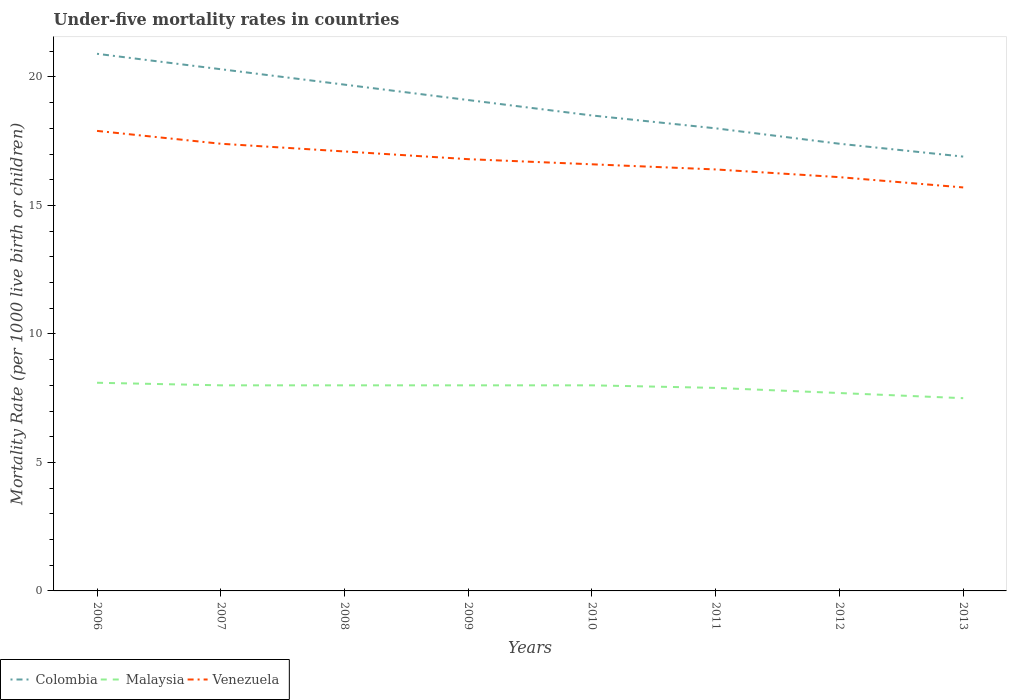Does the line corresponding to Colombia intersect with the line corresponding to Venezuela?
Provide a succinct answer. No. Is the number of lines equal to the number of legend labels?
Give a very brief answer. Yes. Across all years, what is the maximum under-five mortality rate in Colombia?
Provide a short and direct response. 16.9. What is the total under-five mortality rate in Malaysia in the graph?
Your answer should be compact. 0.1. What is the difference between the highest and the second highest under-five mortality rate in Malaysia?
Offer a very short reply. 0.6. How many lines are there?
Your answer should be compact. 3. How many years are there in the graph?
Keep it short and to the point. 8. What is the difference between two consecutive major ticks on the Y-axis?
Keep it short and to the point. 5. Where does the legend appear in the graph?
Provide a succinct answer. Bottom left. What is the title of the graph?
Your answer should be compact. Under-five mortality rates in countries. What is the label or title of the X-axis?
Your answer should be very brief. Years. What is the label or title of the Y-axis?
Offer a terse response. Mortality Rate (per 1000 live birth or children). What is the Mortality Rate (per 1000 live birth or children) of Colombia in 2006?
Give a very brief answer. 20.9. What is the Mortality Rate (per 1000 live birth or children) in Venezuela in 2006?
Your answer should be compact. 17.9. What is the Mortality Rate (per 1000 live birth or children) of Colombia in 2007?
Your answer should be compact. 20.3. What is the Mortality Rate (per 1000 live birth or children) in Malaysia in 2007?
Give a very brief answer. 8. What is the Mortality Rate (per 1000 live birth or children) in Venezuela in 2007?
Offer a very short reply. 17.4. What is the Mortality Rate (per 1000 live birth or children) of Malaysia in 2008?
Give a very brief answer. 8. What is the Mortality Rate (per 1000 live birth or children) in Venezuela in 2008?
Give a very brief answer. 17.1. What is the Mortality Rate (per 1000 live birth or children) of Colombia in 2010?
Ensure brevity in your answer.  18.5. What is the Mortality Rate (per 1000 live birth or children) in Malaysia in 2010?
Ensure brevity in your answer.  8. What is the Mortality Rate (per 1000 live birth or children) in Colombia in 2011?
Provide a succinct answer. 18. What is the Mortality Rate (per 1000 live birth or children) of Malaysia in 2012?
Your response must be concise. 7.7. What is the Mortality Rate (per 1000 live birth or children) in Venezuela in 2013?
Provide a short and direct response. 15.7. Across all years, what is the maximum Mortality Rate (per 1000 live birth or children) of Colombia?
Your response must be concise. 20.9. Across all years, what is the maximum Mortality Rate (per 1000 live birth or children) of Malaysia?
Provide a short and direct response. 8.1. Across all years, what is the minimum Mortality Rate (per 1000 live birth or children) of Malaysia?
Offer a very short reply. 7.5. What is the total Mortality Rate (per 1000 live birth or children) in Colombia in the graph?
Provide a succinct answer. 150.8. What is the total Mortality Rate (per 1000 live birth or children) of Malaysia in the graph?
Ensure brevity in your answer.  63.2. What is the total Mortality Rate (per 1000 live birth or children) of Venezuela in the graph?
Provide a short and direct response. 134. What is the difference between the Mortality Rate (per 1000 live birth or children) in Colombia in 2006 and that in 2007?
Give a very brief answer. 0.6. What is the difference between the Mortality Rate (per 1000 live birth or children) in Malaysia in 2006 and that in 2008?
Give a very brief answer. 0.1. What is the difference between the Mortality Rate (per 1000 live birth or children) in Colombia in 2006 and that in 2009?
Offer a very short reply. 1.8. What is the difference between the Mortality Rate (per 1000 live birth or children) in Colombia in 2006 and that in 2010?
Keep it short and to the point. 2.4. What is the difference between the Mortality Rate (per 1000 live birth or children) of Malaysia in 2006 and that in 2010?
Give a very brief answer. 0.1. What is the difference between the Mortality Rate (per 1000 live birth or children) of Colombia in 2006 and that in 2011?
Offer a terse response. 2.9. What is the difference between the Mortality Rate (per 1000 live birth or children) in Malaysia in 2006 and that in 2011?
Offer a terse response. 0.2. What is the difference between the Mortality Rate (per 1000 live birth or children) in Colombia in 2006 and that in 2012?
Provide a short and direct response. 3.5. What is the difference between the Mortality Rate (per 1000 live birth or children) of Venezuela in 2006 and that in 2012?
Give a very brief answer. 1.8. What is the difference between the Mortality Rate (per 1000 live birth or children) in Venezuela in 2006 and that in 2013?
Offer a terse response. 2.2. What is the difference between the Mortality Rate (per 1000 live birth or children) in Malaysia in 2007 and that in 2008?
Keep it short and to the point. 0. What is the difference between the Mortality Rate (per 1000 live birth or children) of Colombia in 2007 and that in 2009?
Offer a terse response. 1.2. What is the difference between the Mortality Rate (per 1000 live birth or children) of Venezuela in 2007 and that in 2009?
Your answer should be compact. 0.6. What is the difference between the Mortality Rate (per 1000 live birth or children) in Venezuela in 2007 and that in 2010?
Ensure brevity in your answer.  0.8. What is the difference between the Mortality Rate (per 1000 live birth or children) in Colombia in 2007 and that in 2011?
Offer a very short reply. 2.3. What is the difference between the Mortality Rate (per 1000 live birth or children) in Malaysia in 2007 and that in 2011?
Provide a short and direct response. 0.1. What is the difference between the Mortality Rate (per 1000 live birth or children) of Venezuela in 2007 and that in 2011?
Keep it short and to the point. 1. What is the difference between the Mortality Rate (per 1000 live birth or children) in Colombia in 2007 and that in 2012?
Make the answer very short. 2.9. What is the difference between the Mortality Rate (per 1000 live birth or children) of Venezuela in 2007 and that in 2012?
Keep it short and to the point. 1.3. What is the difference between the Mortality Rate (per 1000 live birth or children) in Malaysia in 2007 and that in 2013?
Your answer should be compact. 0.5. What is the difference between the Mortality Rate (per 1000 live birth or children) in Venezuela in 2007 and that in 2013?
Keep it short and to the point. 1.7. What is the difference between the Mortality Rate (per 1000 live birth or children) in Colombia in 2008 and that in 2009?
Your answer should be very brief. 0.6. What is the difference between the Mortality Rate (per 1000 live birth or children) in Malaysia in 2008 and that in 2009?
Offer a very short reply. 0. What is the difference between the Mortality Rate (per 1000 live birth or children) in Venezuela in 2008 and that in 2009?
Ensure brevity in your answer.  0.3. What is the difference between the Mortality Rate (per 1000 live birth or children) in Venezuela in 2008 and that in 2010?
Ensure brevity in your answer.  0.5. What is the difference between the Mortality Rate (per 1000 live birth or children) in Venezuela in 2008 and that in 2013?
Your response must be concise. 1.4. What is the difference between the Mortality Rate (per 1000 live birth or children) of Colombia in 2009 and that in 2010?
Your answer should be very brief. 0.6. What is the difference between the Mortality Rate (per 1000 live birth or children) in Malaysia in 2009 and that in 2010?
Keep it short and to the point. 0. What is the difference between the Mortality Rate (per 1000 live birth or children) of Venezuela in 2009 and that in 2010?
Offer a very short reply. 0.2. What is the difference between the Mortality Rate (per 1000 live birth or children) in Malaysia in 2009 and that in 2013?
Keep it short and to the point. 0.5. What is the difference between the Mortality Rate (per 1000 live birth or children) of Venezuela in 2009 and that in 2013?
Your answer should be compact. 1.1. What is the difference between the Mortality Rate (per 1000 live birth or children) of Malaysia in 2010 and that in 2011?
Offer a very short reply. 0.1. What is the difference between the Mortality Rate (per 1000 live birth or children) of Colombia in 2010 and that in 2012?
Give a very brief answer. 1.1. What is the difference between the Mortality Rate (per 1000 live birth or children) of Malaysia in 2010 and that in 2012?
Keep it short and to the point. 0.3. What is the difference between the Mortality Rate (per 1000 live birth or children) in Venezuela in 2010 and that in 2012?
Keep it short and to the point. 0.5. What is the difference between the Mortality Rate (per 1000 live birth or children) in Colombia in 2011 and that in 2013?
Your answer should be very brief. 1.1. What is the difference between the Mortality Rate (per 1000 live birth or children) of Colombia in 2012 and that in 2013?
Offer a terse response. 0.5. What is the difference between the Mortality Rate (per 1000 live birth or children) of Malaysia in 2012 and that in 2013?
Keep it short and to the point. 0.2. What is the difference between the Mortality Rate (per 1000 live birth or children) of Colombia in 2006 and the Mortality Rate (per 1000 live birth or children) of Malaysia in 2007?
Your response must be concise. 12.9. What is the difference between the Mortality Rate (per 1000 live birth or children) of Colombia in 2006 and the Mortality Rate (per 1000 live birth or children) of Malaysia in 2008?
Offer a very short reply. 12.9. What is the difference between the Mortality Rate (per 1000 live birth or children) of Colombia in 2006 and the Mortality Rate (per 1000 live birth or children) of Venezuela in 2008?
Your response must be concise. 3.8. What is the difference between the Mortality Rate (per 1000 live birth or children) in Malaysia in 2006 and the Mortality Rate (per 1000 live birth or children) in Venezuela in 2008?
Offer a terse response. -9. What is the difference between the Mortality Rate (per 1000 live birth or children) in Colombia in 2006 and the Mortality Rate (per 1000 live birth or children) in Malaysia in 2010?
Your response must be concise. 12.9. What is the difference between the Mortality Rate (per 1000 live birth or children) of Colombia in 2006 and the Mortality Rate (per 1000 live birth or children) of Venezuela in 2010?
Keep it short and to the point. 4.3. What is the difference between the Mortality Rate (per 1000 live birth or children) in Colombia in 2006 and the Mortality Rate (per 1000 live birth or children) in Malaysia in 2011?
Your response must be concise. 13. What is the difference between the Mortality Rate (per 1000 live birth or children) in Malaysia in 2006 and the Mortality Rate (per 1000 live birth or children) in Venezuela in 2011?
Give a very brief answer. -8.3. What is the difference between the Mortality Rate (per 1000 live birth or children) in Colombia in 2006 and the Mortality Rate (per 1000 live birth or children) in Malaysia in 2013?
Provide a short and direct response. 13.4. What is the difference between the Mortality Rate (per 1000 live birth or children) in Colombia in 2006 and the Mortality Rate (per 1000 live birth or children) in Venezuela in 2013?
Provide a short and direct response. 5.2. What is the difference between the Mortality Rate (per 1000 live birth or children) of Colombia in 2007 and the Mortality Rate (per 1000 live birth or children) of Malaysia in 2008?
Provide a short and direct response. 12.3. What is the difference between the Mortality Rate (per 1000 live birth or children) of Malaysia in 2007 and the Mortality Rate (per 1000 live birth or children) of Venezuela in 2008?
Your answer should be very brief. -9.1. What is the difference between the Mortality Rate (per 1000 live birth or children) in Colombia in 2007 and the Mortality Rate (per 1000 live birth or children) in Malaysia in 2009?
Provide a succinct answer. 12.3. What is the difference between the Mortality Rate (per 1000 live birth or children) of Colombia in 2007 and the Mortality Rate (per 1000 live birth or children) of Malaysia in 2010?
Give a very brief answer. 12.3. What is the difference between the Mortality Rate (per 1000 live birth or children) in Colombia in 2007 and the Mortality Rate (per 1000 live birth or children) in Venezuela in 2010?
Provide a short and direct response. 3.7. What is the difference between the Mortality Rate (per 1000 live birth or children) of Colombia in 2007 and the Mortality Rate (per 1000 live birth or children) of Malaysia in 2013?
Your response must be concise. 12.8. What is the difference between the Mortality Rate (per 1000 live birth or children) of Malaysia in 2007 and the Mortality Rate (per 1000 live birth or children) of Venezuela in 2013?
Offer a very short reply. -7.7. What is the difference between the Mortality Rate (per 1000 live birth or children) of Colombia in 2008 and the Mortality Rate (per 1000 live birth or children) of Venezuela in 2010?
Your answer should be compact. 3.1. What is the difference between the Mortality Rate (per 1000 live birth or children) in Colombia in 2008 and the Mortality Rate (per 1000 live birth or children) in Malaysia in 2011?
Keep it short and to the point. 11.8. What is the difference between the Mortality Rate (per 1000 live birth or children) of Malaysia in 2008 and the Mortality Rate (per 1000 live birth or children) of Venezuela in 2011?
Offer a terse response. -8.4. What is the difference between the Mortality Rate (per 1000 live birth or children) of Colombia in 2008 and the Mortality Rate (per 1000 live birth or children) of Malaysia in 2012?
Your answer should be compact. 12. What is the difference between the Mortality Rate (per 1000 live birth or children) in Colombia in 2008 and the Mortality Rate (per 1000 live birth or children) in Malaysia in 2013?
Make the answer very short. 12.2. What is the difference between the Mortality Rate (per 1000 live birth or children) in Colombia in 2008 and the Mortality Rate (per 1000 live birth or children) in Venezuela in 2013?
Provide a succinct answer. 4. What is the difference between the Mortality Rate (per 1000 live birth or children) of Colombia in 2009 and the Mortality Rate (per 1000 live birth or children) of Venezuela in 2010?
Your answer should be compact. 2.5. What is the difference between the Mortality Rate (per 1000 live birth or children) in Malaysia in 2009 and the Mortality Rate (per 1000 live birth or children) in Venezuela in 2010?
Provide a succinct answer. -8.6. What is the difference between the Mortality Rate (per 1000 live birth or children) of Colombia in 2009 and the Mortality Rate (per 1000 live birth or children) of Malaysia in 2011?
Ensure brevity in your answer.  11.2. What is the difference between the Mortality Rate (per 1000 live birth or children) of Colombia in 2009 and the Mortality Rate (per 1000 live birth or children) of Venezuela in 2011?
Provide a short and direct response. 2.7. What is the difference between the Mortality Rate (per 1000 live birth or children) in Malaysia in 2009 and the Mortality Rate (per 1000 live birth or children) in Venezuela in 2011?
Ensure brevity in your answer.  -8.4. What is the difference between the Mortality Rate (per 1000 live birth or children) in Colombia in 2009 and the Mortality Rate (per 1000 live birth or children) in Venezuela in 2012?
Provide a short and direct response. 3. What is the difference between the Mortality Rate (per 1000 live birth or children) of Malaysia in 2009 and the Mortality Rate (per 1000 live birth or children) of Venezuela in 2012?
Offer a terse response. -8.1. What is the difference between the Mortality Rate (per 1000 live birth or children) in Colombia in 2009 and the Mortality Rate (per 1000 live birth or children) in Malaysia in 2013?
Offer a terse response. 11.6. What is the difference between the Mortality Rate (per 1000 live birth or children) of Colombia in 2009 and the Mortality Rate (per 1000 live birth or children) of Venezuela in 2013?
Offer a very short reply. 3.4. What is the difference between the Mortality Rate (per 1000 live birth or children) of Malaysia in 2009 and the Mortality Rate (per 1000 live birth or children) of Venezuela in 2013?
Your answer should be compact. -7.7. What is the difference between the Mortality Rate (per 1000 live birth or children) in Colombia in 2010 and the Mortality Rate (per 1000 live birth or children) in Malaysia in 2011?
Your response must be concise. 10.6. What is the difference between the Mortality Rate (per 1000 live birth or children) in Colombia in 2010 and the Mortality Rate (per 1000 live birth or children) in Venezuela in 2011?
Make the answer very short. 2.1. What is the difference between the Mortality Rate (per 1000 live birth or children) in Colombia in 2010 and the Mortality Rate (per 1000 live birth or children) in Venezuela in 2012?
Offer a very short reply. 2.4. What is the difference between the Mortality Rate (per 1000 live birth or children) in Malaysia in 2010 and the Mortality Rate (per 1000 live birth or children) in Venezuela in 2012?
Offer a terse response. -8.1. What is the difference between the Mortality Rate (per 1000 live birth or children) in Malaysia in 2011 and the Mortality Rate (per 1000 live birth or children) in Venezuela in 2012?
Keep it short and to the point. -8.2. What is the difference between the Mortality Rate (per 1000 live birth or children) in Colombia in 2011 and the Mortality Rate (per 1000 live birth or children) in Venezuela in 2013?
Make the answer very short. 2.3. What is the difference between the Mortality Rate (per 1000 live birth or children) in Colombia in 2012 and the Mortality Rate (per 1000 live birth or children) in Venezuela in 2013?
Offer a very short reply. 1.7. What is the average Mortality Rate (per 1000 live birth or children) of Colombia per year?
Your answer should be compact. 18.85. What is the average Mortality Rate (per 1000 live birth or children) in Malaysia per year?
Provide a succinct answer. 7.9. What is the average Mortality Rate (per 1000 live birth or children) in Venezuela per year?
Offer a terse response. 16.75. In the year 2006, what is the difference between the Mortality Rate (per 1000 live birth or children) in Colombia and Mortality Rate (per 1000 live birth or children) in Venezuela?
Offer a very short reply. 3. In the year 2007, what is the difference between the Mortality Rate (per 1000 live birth or children) of Malaysia and Mortality Rate (per 1000 live birth or children) of Venezuela?
Keep it short and to the point. -9.4. In the year 2008, what is the difference between the Mortality Rate (per 1000 live birth or children) in Colombia and Mortality Rate (per 1000 live birth or children) in Malaysia?
Keep it short and to the point. 11.7. In the year 2008, what is the difference between the Mortality Rate (per 1000 live birth or children) in Colombia and Mortality Rate (per 1000 live birth or children) in Venezuela?
Keep it short and to the point. 2.6. In the year 2008, what is the difference between the Mortality Rate (per 1000 live birth or children) of Malaysia and Mortality Rate (per 1000 live birth or children) of Venezuela?
Provide a short and direct response. -9.1. In the year 2009, what is the difference between the Mortality Rate (per 1000 live birth or children) in Colombia and Mortality Rate (per 1000 live birth or children) in Venezuela?
Make the answer very short. 2.3. In the year 2009, what is the difference between the Mortality Rate (per 1000 live birth or children) in Malaysia and Mortality Rate (per 1000 live birth or children) in Venezuela?
Ensure brevity in your answer.  -8.8. In the year 2010, what is the difference between the Mortality Rate (per 1000 live birth or children) in Colombia and Mortality Rate (per 1000 live birth or children) in Venezuela?
Offer a very short reply. 1.9. In the year 2010, what is the difference between the Mortality Rate (per 1000 live birth or children) in Malaysia and Mortality Rate (per 1000 live birth or children) in Venezuela?
Give a very brief answer. -8.6. In the year 2011, what is the difference between the Mortality Rate (per 1000 live birth or children) of Colombia and Mortality Rate (per 1000 live birth or children) of Malaysia?
Your answer should be very brief. 10.1. In the year 2011, what is the difference between the Mortality Rate (per 1000 live birth or children) in Malaysia and Mortality Rate (per 1000 live birth or children) in Venezuela?
Your response must be concise. -8.5. In the year 2012, what is the difference between the Mortality Rate (per 1000 live birth or children) in Colombia and Mortality Rate (per 1000 live birth or children) in Venezuela?
Your response must be concise. 1.3. In the year 2012, what is the difference between the Mortality Rate (per 1000 live birth or children) of Malaysia and Mortality Rate (per 1000 live birth or children) of Venezuela?
Your answer should be very brief. -8.4. In the year 2013, what is the difference between the Mortality Rate (per 1000 live birth or children) in Colombia and Mortality Rate (per 1000 live birth or children) in Malaysia?
Keep it short and to the point. 9.4. In the year 2013, what is the difference between the Mortality Rate (per 1000 live birth or children) in Colombia and Mortality Rate (per 1000 live birth or children) in Venezuela?
Your answer should be compact. 1.2. What is the ratio of the Mortality Rate (per 1000 live birth or children) in Colombia in 2006 to that in 2007?
Make the answer very short. 1.03. What is the ratio of the Mortality Rate (per 1000 live birth or children) of Malaysia in 2006 to that in 2007?
Give a very brief answer. 1.01. What is the ratio of the Mortality Rate (per 1000 live birth or children) in Venezuela in 2006 to that in 2007?
Ensure brevity in your answer.  1.03. What is the ratio of the Mortality Rate (per 1000 live birth or children) in Colombia in 2006 to that in 2008?
Make the answer very short. 1.06. What is the ratio of the Mortality Rate (per 1000 live birth or children) of Malaysia in 2006 to that in 2008?
Ensure brevity in your answer.  1.01. What is the ratio of the Mortality Rate (per 1000 live birth or children) of Venezuela in 2006 to that in 2008?
Provide a short and direct response. 1.05. What is the ratio of the Mortality Rate (per 1000 live birth or children) in Colombia in 2006 to that in 2009?
Ensure brevity in your answer.  1.09. What is the ratio of the Mortality Rate (per 1000 live birth or children) of Malaysia in 2006 to that in 2009?
Offer a terse response. 1.01. What is the ratio of the Mortality Rate (per 1000 live birth or children) of Venezuela in 2006 to that in 2009?
Your answer should be very brief. 1.07. What is the ratio of the Mortality Rate (per 1000 live birth or children) in Colombia in 2006 to that in 2010?
Your answer should be compact. 1.13. What is the ratio of the Mortality Rate (per 1000 live birth or children) in Malaysia in 2006 to that in 2010?
Your answer should be very brief. 1.01. What is the ratio of the Mortality Rate (per 1000 live birth or children) in Venezuela in 2006 to that in 2010?
Offer a very short reply. 1.08. What is the ratio of the Mortality Rate (per 1000 live birth or children) in Colombia in 2006 to that in 2011?
Ensure brevity in your answer.  1.16. What is the ratio of the Mortality Rate (per 1000 live birth or children) of Malaysia in 2006 to that in 2011?
Offer a very short reply. 1.03. What is the ratio of the Mortality Rate (per 1000 live birth or children) of Venezuela in 2006 to that in 2011?
Your response must be concise. 1.09. What is the ratio of the Mortality Rate (per 1000 live birth or children) in Colombia in 2006 to that in 2012?
Offer a terse response. 1.2. What is the ratio of the Mortality Rate (per 1000 live birth or children) in Malaysia in 2006 to that in 2012?
Offer a very short reply. 1.05. What is the ratio of the Mortality Rate (per 1000 live birth or children) of Venezuela in 2006 to that in 2012?
Ensure brevity in your answer.  1.11. What is the ratio of the Mortality Rate (per 1000 live birth or children) of Colombia in 2006 to that in 2013?
Your answer should be compact. 1.24. What is the ratio of the Mortality Rate (per 1000 live birth or children) of Malaysia in 2006 to that in 2013?
Keep it short and to the point. 1.08. What is the ratio of the Mortality Rate (per 1000 live birth or children) of Venezuela in 2006 to that in 2013?
Give a very brief answer. 1.14. What is the ratio of the Mortality Rate (per 1000 live birth or children) of Colombia in 2007 to that in 2008?
Keep it short and to the point. 1.03. What is the ratio of the Mortality Rate (per 1000 live birth or children) in Venezuela in 2007 to that in 2008?
Keep it short and to the point. 1.02. What is the ratio of the Mortality Rate (per 1000 live birth or children) in Colombia in 2007 to that in 2009?
Offer a terse response. 1.06. What is the ratio of the Mortality Rate (per 1000 live birth or children) of Venezuela in 2007 to that in 2009?
Provide a succinct answer. 1.04. What is the ratio of the Mortality Rate (per 1000 live birth or children) in Colombia in 2007 to that in 2010?
Keep it short and to the point. 1.1. What is the ratio of the Mortality Rate (per 1000 live birth or children) of Venezuela in 2007 to that in 2010?
Offer a terse response. 1.05. What is the ratio of the Mortality Rate (per 1000 live birth or children) of Colombia in 2007 to that in 2011?
Make the answer very short. 1.13. What is the ratio of the Mortality Rate (per 1000 live birth or children) of Malaysia in 2007 to that in 2011?
Provide a succinct answer. 1.01. What is the ratio of the Mortality Rate (per 1000 live birth or children) of Venezuela in 2007 to that in 2011?
Keep it short and to the point. 1.06. What is the ratio of the Mortality Rate (per 1000 live birth or children) in Malaysia in 2007 to that in 2012?
Give a very brief answer. 1.04. What is the ratio of the Mortality Rate (per 1000 live birth or children) in Venezuela in 2007 to that in 2012?
Provide a succinct answer. 1.08. What is the ratio of the Mortality Rate (per 1000 live birth or children) in Colombia in 2007 to that in 2013?
Your response must be concise. 1.2. What is the ratio of the Mortality Rate (per 1000 live birth or children) of Malaysia in 2007 to that in 2013?
Keep it short and to the point. 1.07. What is the ratio of the Mortality Rate (per 1000 live birth or children) of Venezuela in 2007 to that in 2013?
Provide a succinct answer. 1.11. What is the ratio of the Mortality Rate (per 1000 live birth or children) in Colombia in 2008 to that in 2009?
Your answer should be compact. 1.03. What is the ratio of the Mortality Rate (per 1000 live birth or children) in Malaysia in 2008 to that in 2009?
Give a very brief answer. 1. What is the ratio of the Mortality Rate (per 1000 live birth or children) of Venezuela in 2008 to that in 2009?
Your answer should be very brief. 1.02. What is the ratio of the Mortality Rate (per 1000 live birth or children) of Colombia in 2008 to that in 2010?
Provide a succinct answer. 1.06. What is the ratio of the Mortality Rate (per 1000 live birth or children) of Malaysia in 2008 to that in 2010?
Ensure brevity in your answer.  1. What is the ratio of the Mortality Rate (per 1000 live birth or children) in Venezuela in 2008 to that in 2010?
Keep it short and to the point. 1.03. What is the ratio of the Mortality Rate (per 1000 live birth or children) of Colombia in 2008 to that in 2011?
Keep it short and to the point. 1.09. What is the ratio of the Mortality Rate (per 1000 live birth or children) of Malaysia in 2008 to that in 2011?
Your answer should be compact. 1.01. What is the ratio of the Mortality Rate (per 1000 live birth or children) in Venezuela in 2008 to that in 2011?
Offer a terse response. 1.04. What is the ratio of the Mortality Rate (per 1000 live birth or children) of Colombia in 2008 to that in 2012?
Offer a very short reply. 1.13. What is the ratio of the Mortality Rate (per 1000 live birth or children) in Malaysia in 2008 to that in 2012?
Provide a succinct answer. 1.04. What is the ratio of the Mortality Rate (per 1000 live birth or children) of Venezuela in 2008 to that in 2012?
Make the answer very short. 1.06. What is the ratio of the Mortality Rate (per 1000 live birth or children) in Colombia in 2008 to that in 2013?
Provide a succinct answer. 1.17. What is the ratio of the Mortality Rate (per 1000 live birth or children) of Malaysia in 2008 to that in 2013?
Keep it short and to the point. 1.07. What is the ratio of the Mortality Rate (per 1000 live birth or children) of Venezuela in 2008 to that in 2013?
Ensure brevity in your answer.  1.09. What is the ratio of the Mortality Rate (per 1000 live birth or children) in Colombia in 2009 to that in 2010?
Ensure brevity in your answer.  1.03. What is the ratio of the Mortality Rate (per 1000 live birth or children) in Venezuela in 2009 to that in 2010?
Provide a succinct answer. 1.01. What is the ratio of the Mortality Rate (per 1000 live birth or children) of Colombia in 2009 to that in 2011?
Your response must be concise. 1.06. What is the ratio of the Mortality Rate (per 1000 live birth or children) in Malaysia in 2009 to that in 2011?
Your answer should be compact. 1.01. What is the ratio of the Mortality Rate (per 1000 live birth or children) in Venezuela in 2009 to that in 2011?
Your answer should be very brief. 1.02. What is the ratio of the Mortality Rate (per 1000 live birth or children) in Colombia in 2009 to that in 2012?
Your response must be concise. 1.1. What is the ratio of the Mortality Rate (per 1000 live birth or children) in Malaysia in 2009 to that in 2012?
Offer a very short reply. 1.04. What is the ratio of the Mortality Rate (per 1000 live birth or children) of Venezuela in 2009 to that in 2012?
Keep it short and to the point. 1.04. What is the ratio of the Mortality Rate (per 1000 live birth or children) in Colombia in 2009 to that in 2013?
Your answer should be compact. 1.13. What is the ratio of the Mortality Rate (per 1000 live birth or children) of Malaysia in 2009 to that in 2013?
Make the answer very short. 1.07. What is the ratio of the Mortality Rate (per 1000 live birth or children) of Venezuela in 2009 to that in 2013?
Give a very brief answer. 1.07. What is the ratio of the Mortality Rate (per 1000 live birth or children) in Colombia in 2010 to that in 2011?
Your response must be concise. 1.03. What is the ratio of the Mortality Rate (per 1000 live birth or children) of Malaysia in 2010 to that in 2011?
Keep it short and to the point. 1.01. What is the ratio of the Mortality Rate (per 1000 live birth or children) of Venezuela in 2010 to that in 2011?
Your response must be concise. 1.01. What is the ratio of the Mortality Rate (per 1000 live birth or children) in Colombia in 2010 to that in 2012?
Your answer should be very brief. 1.06. What is the ratio of the Mortality Rate (per 1000 live birth or children) in Malaysia in 2010 to that in 2012?
Keep it short and to the point. 1.04. What is the ratio of the Mortality Rate (per 1000 live birth or children) of Venezuela in 2010 to that in 2012?
Ensure brevity in your answer.  1.03. What is the ratio of the Mortality Rate (per 1000 live birth or children) of Colombia in 2010 to that in 2013?
Provide a succinct answer. 1.09. What is the ratio of the Mortality Rate (per 1000 live birth or children) in Malaysia in 2010 to that in 2013?
Offer a terse response. 1.07. What is the ratio of the Mortality Rate (per 1000 live birth or children) of Venezuela in 2010 to that in 2013?
Give a very brief answer. 1.06. What is the ratio of the Mortality Rate (per 1000 live birth or children) of Colombia in 2011 to that in 2012?
Your response must be concise. 1.03. What is the ratio of the Mortality Rate (per 1000 live birth or children) of Venezuela in 2011 to that in 2012?
Give a very brief answer. 1.02. What is the ratio of the Mortality Rate (per 1000 live birth or children) in Colombia in 2011 to that in 2013?
Ensure brevity in your answer.  1.07. What is the ratio of the Mortality Rate (per 1000 live birth or children) in Malaysia in 2011 to that in 2013?
Your answer should be very brief. 1.05. What is the ratio of the Mortality Rate (per 1000 live birth or children) of Venezuela in 2011 to that in 2013?
Give a very brief answer. 1.04. What is the ratio of the Mortality Rate (per 1000 live birth or children) of Colombia in 2012 to that in 2013?
Your answer should be compact. 1.03. What is the ratio of the Mortality Rate (per 1000 live birth or children) in Malaysia in 2012 to that in 2013?
Make the answer very short. 1.03. What is the ratio of the Mortality Rate (per 1000 live birth or children) in Venezuela in 2012 to that in 2013?
Ensure brevity in your answer.  1.03. What is the difference between the highest and the lowest Mortality Rate (per 1000 live birth or children) in Malaysia?
Your response must be concise. 0.6. 